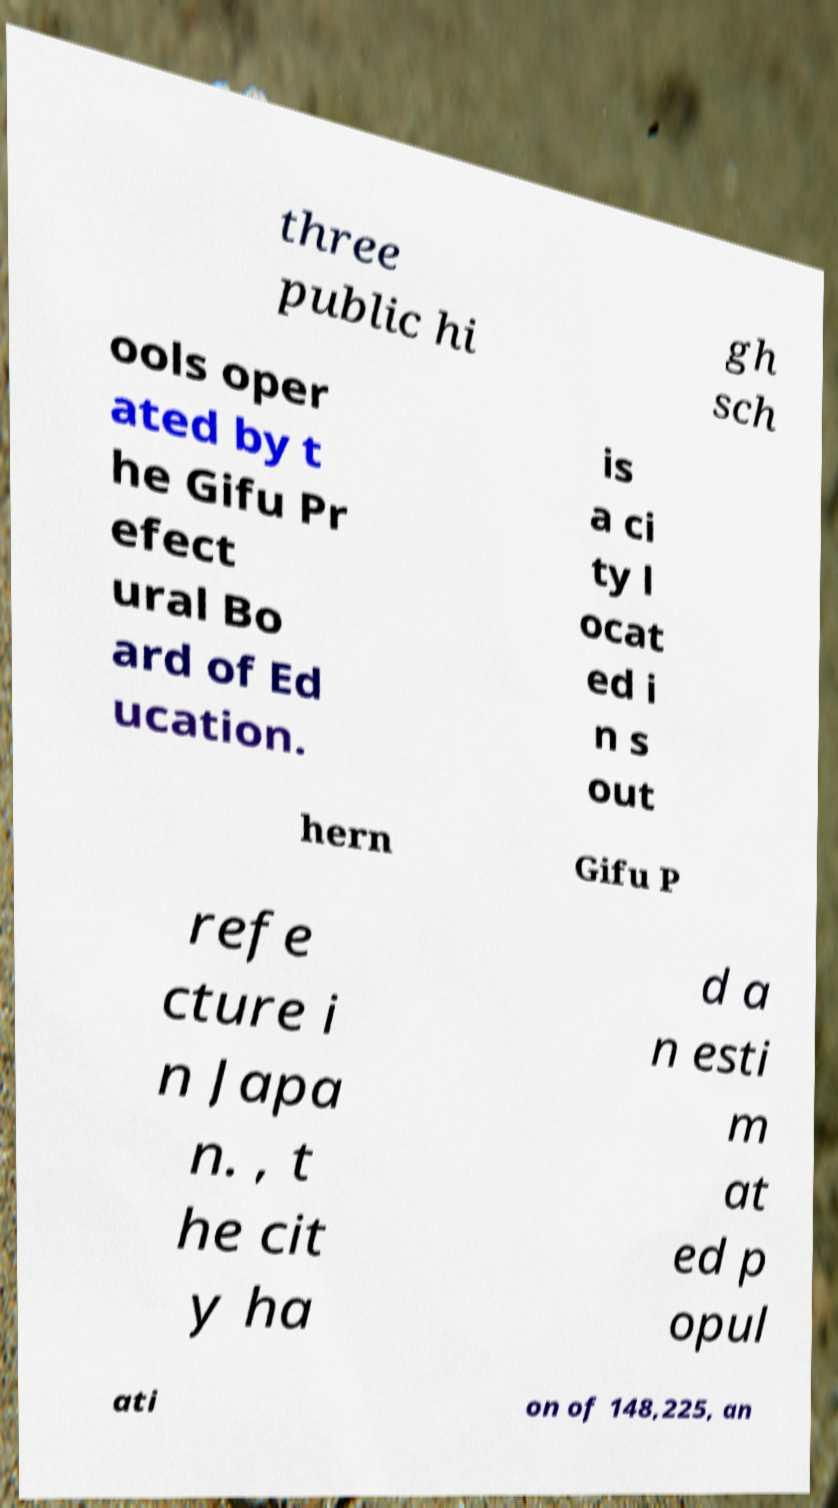Could you extract and type out the text from this image? three public hi gh sch ools oper ated by t he Gifu Pr efect ural Bo ard of Ed ucation. is a ci ty l ocat ed i n s out hern Gifu P refe cture i n Japa n. , t he cit y ha d a n esti m at ed p opul ati on of 148,225, an 